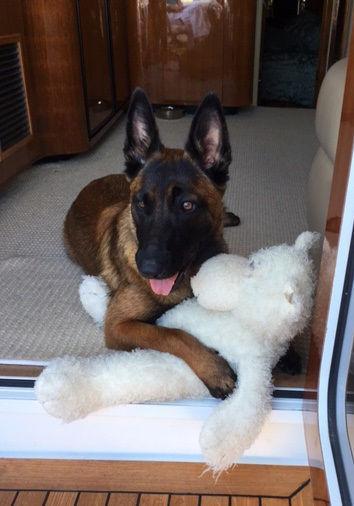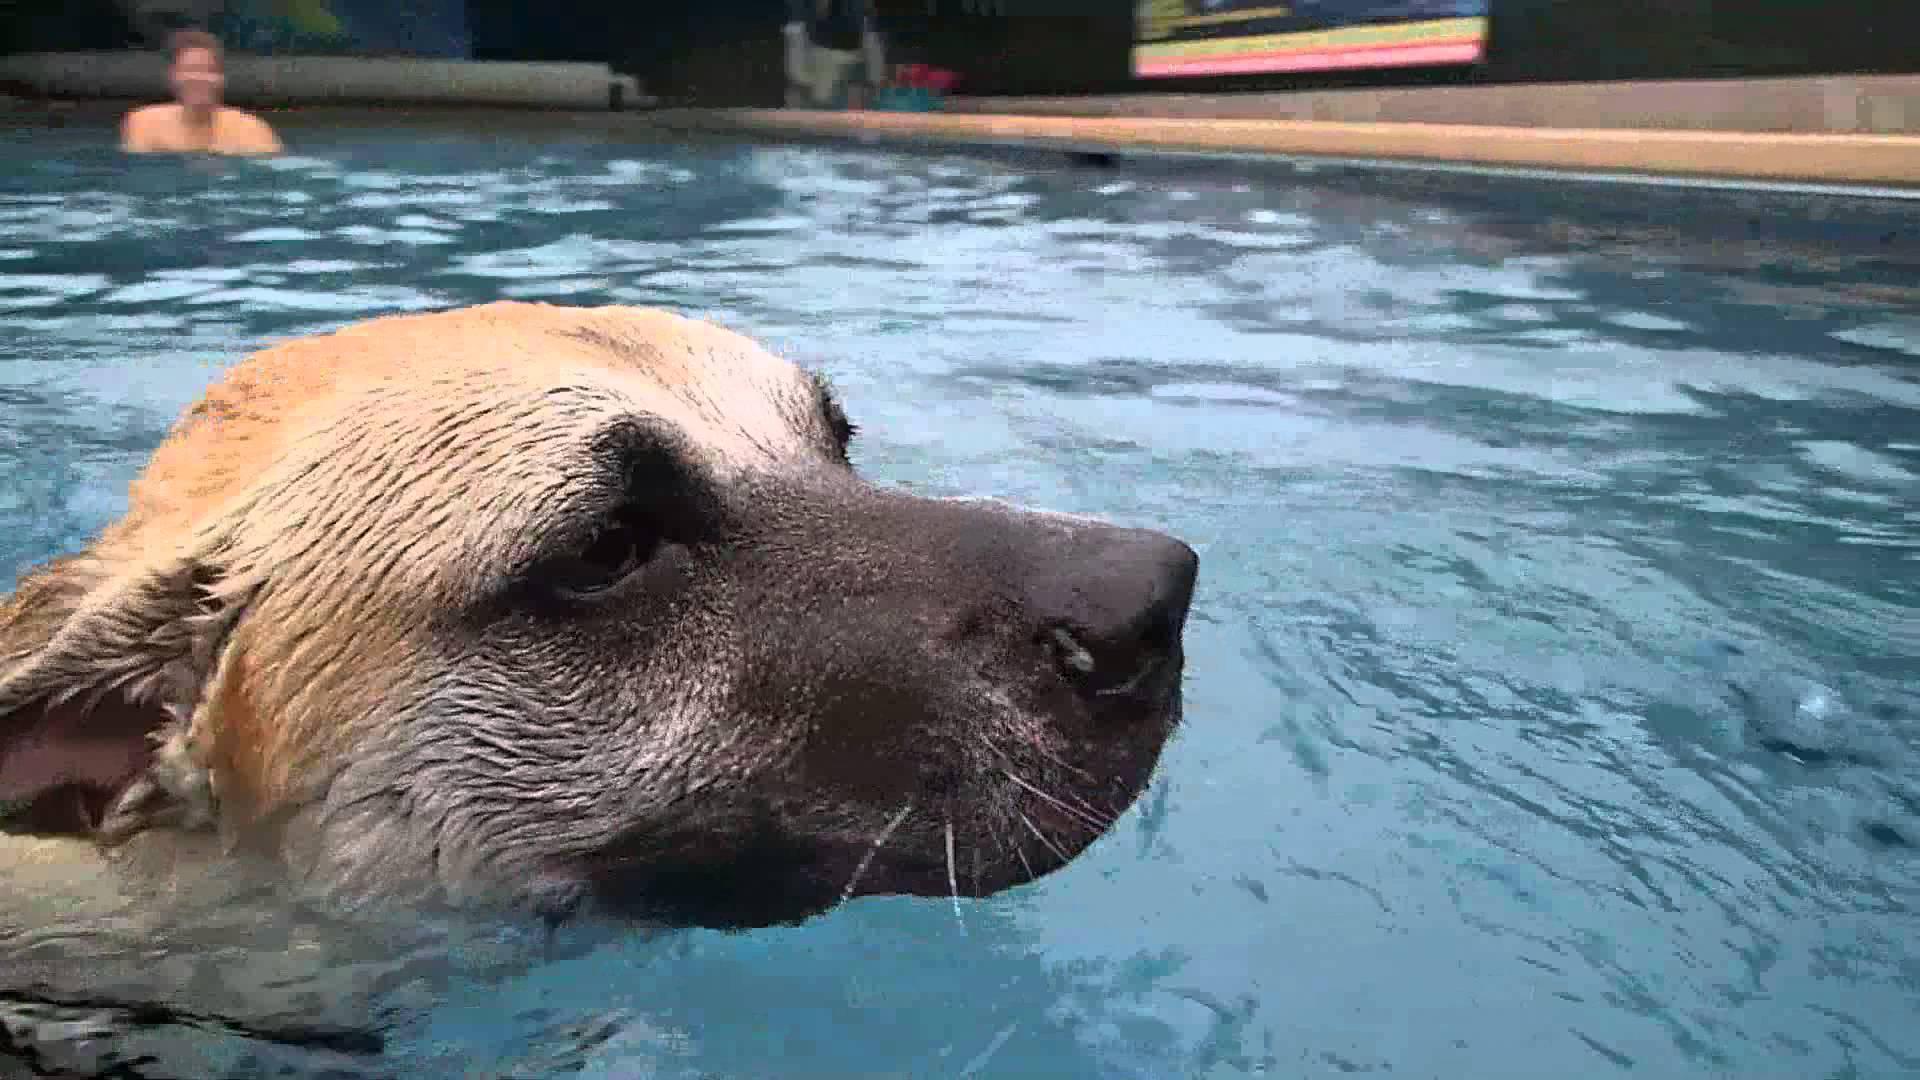The first image is the image on the left, the second image is the image on the right. Considering the images on both sides, is "A dog is in a jumping pose splashing over water, facing leftward with front paws extended." valid? Answer yes or no. No. The first image is the image on the left, the second image is the image on the right. Given the left and right images, does the statement "An image contains a dog jumping in water." hold true? Answer yes or no. No. 